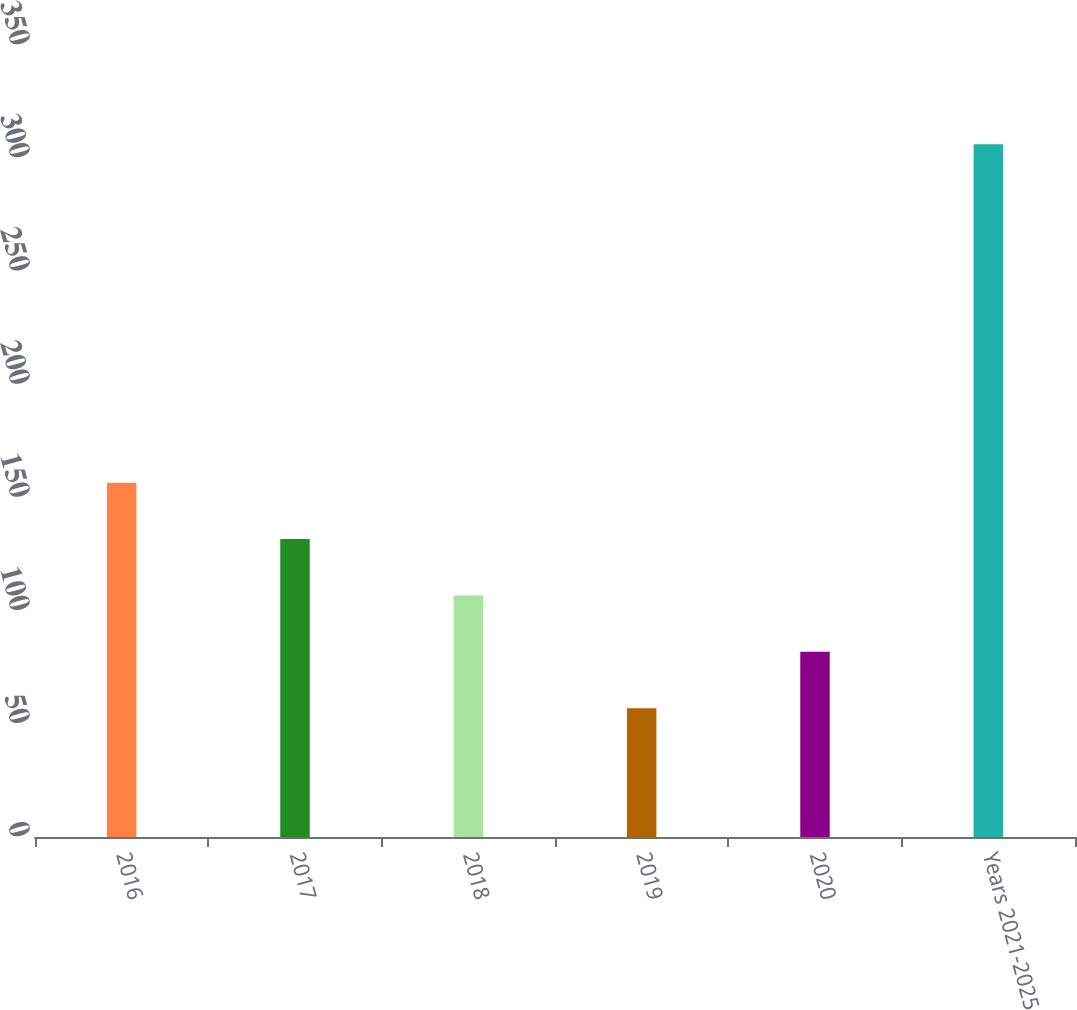Convert chart to OTSL. <chart><loc_0><loc_0><loc_500><loc_500><bar_chart><fcel>2016<fcel>2017<fcel>2018<fcel>2019<fcel>2020<fcel>Years 2021-2025<nl><fcel>156.58<fcel>131.66<fcel>106.74<fcel>56.9<fcel>81.82<fcel>306.1<nl></chart> 